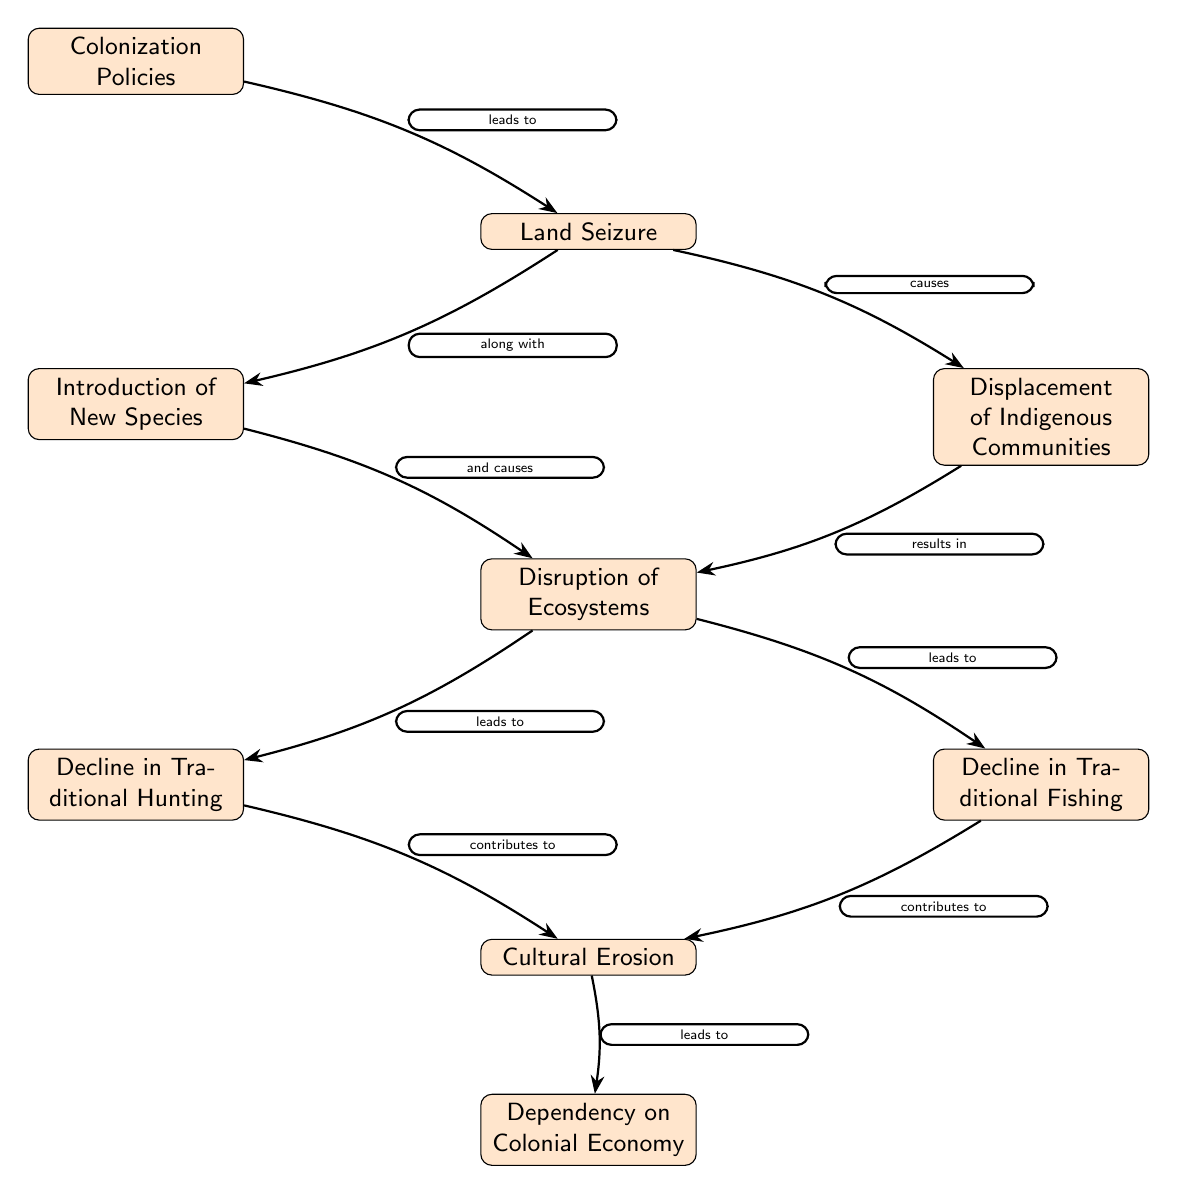What is the first node in the diagram? The first node is labeled "Colonization Policies," which is at the top of the diagram.
Answer: Colonization Policies How many total nodes are there in the diagram? Counting all distinct nodes from the top to the bottom of the diagram, there are a total of 9 nodes shown.
Answer: 9 What does "Land Seizure" lead to? The diagram indicates that "Land Seizure" leads to two direct consequences: "Displacement of Indigenous Communities" and "Introduction of New Species."
Answer: Displacement of Indigenous Communities and Introduction of New Species What is the relationship between "Disruption of Ecosystems" and "Decline in Traditional Hunting"? According to the diagram, "Disruption of Ecosystems" leads to "Decline in Traditional Hunting," showing a direct cause-and-effect relationship between these two nodes.
Answer: leads to Which two nodes contribute to "Cultural Erosion"? The nodes that contribute to "Cultural Erosion" are "Decline in Traditional Hunting" and "Decline in Traditional Fishing," both of which directly connect to "Cultural Erosion."
Answer: Decline in Traditional Hunting and Decline in Traditional Fishing What do "Decline in Traditional Hunting" and "Decline in Traditional Fishing" result in collectively? Both nodes lead to a common outcome labeled "Cultural Erosion," showing a combined effect of declining traditional practices.
Answer: Cultural Erosion How does "Colonization Policies" impact ecosystems according to the diagram? "Colonization Policies" impacts ecosystems through "Land Seizure," which causes "Displacement of Indigenous Communities" and introduces new species, ultimately leading to "Disruption of Ecosystems." This shows a chain reaction starting from colonization policies.
Answer: Disruption of Ecosystems What is the final node in the diagram? The final node at the bottom of the diagram is "Dependency on Colonial Economy," which is the last outcome of the chain related to the effects of colonization.
Answer: Dependency on Colonial Economy 